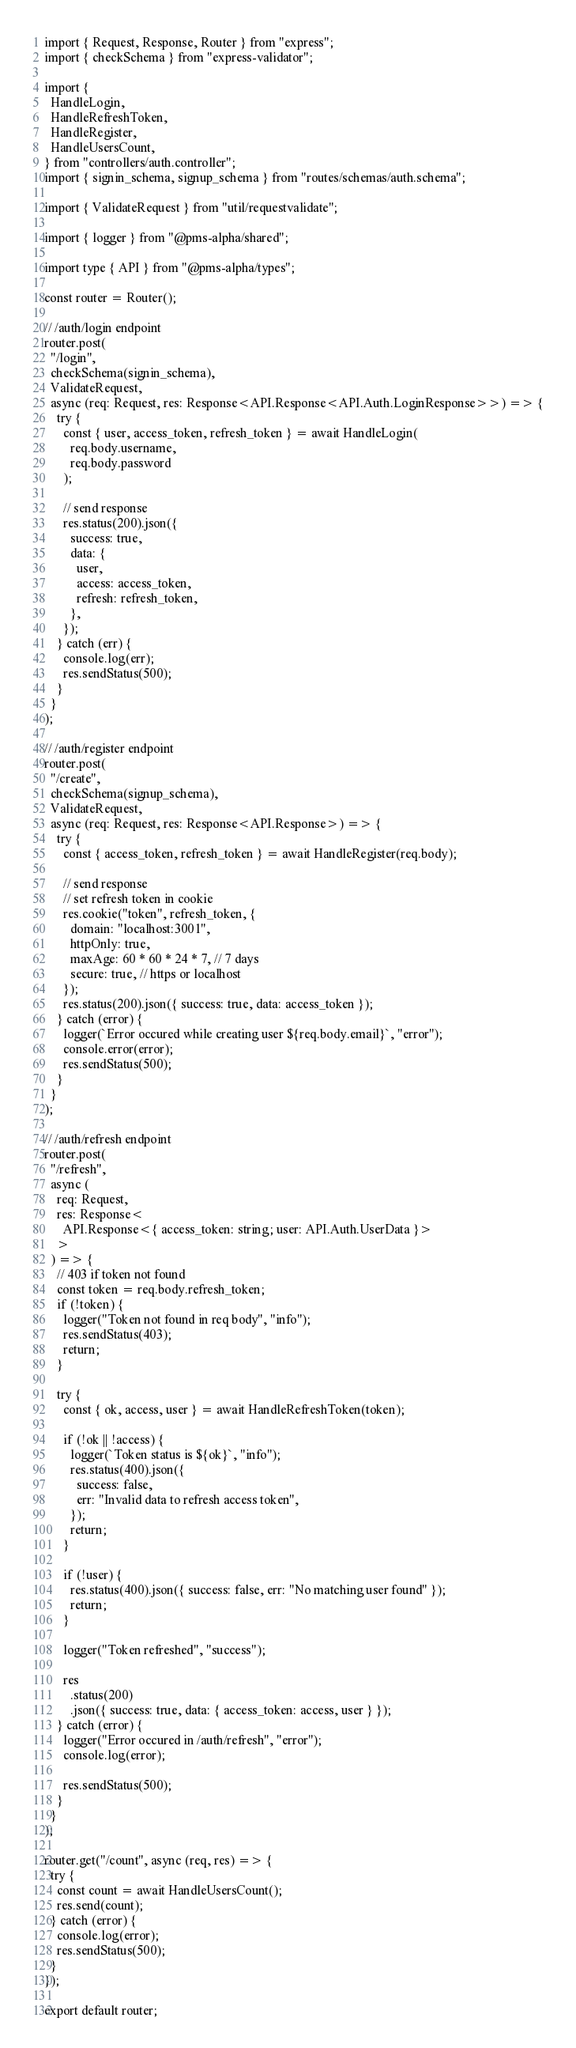<code> <loc_0><loc_0><loc_500><loc_500><_TypeScript_>import { Request, Response, Router } from "express";
import { checkSchema } from "express-validator";

import {
  HandleLogin,
  HandleRefreshToken,
  HandleRegister,
  HandleUsersCount,
} from "controllers/auth.controller";
import { signin_schema, signup_schema } from "routes/schemas/auth.schema";

import { ValidateRequest } from "util/requestvalidate";

import { logger } from "@pms-alpha/shared";

import type { API } from "@pms-alpha/types";

const router = Router();

// /auth/login endpoint
router.post(
  "/login",
  checkSchema(signin_schema),
  ValidateRequest,
  async (req: Request, res: Response<API.Response<API.Auth.LoginResponse>>) => {
    try {
      const { user, access_token, refresh_token } = await HandleLogin(
        req.body.username,
        req.body.password
      );

      // send response
      res.status(200).json({
        success: true,
        data: {
          user,
          access: access_token,
          refresh: refresh_token,
        },
      });
    } catch (err) {
      console.log(err);
      res.sendStatus(500);
    }
  }
);

// /auth/register endpoint
router.post(
  "/create",
  checkSchema(signup_schema),
  ValidateRequest,
  async (req: Request, res: Response<API.Response>) => {
    try {
      const { access_token, refresh_token } = await HandleRegister(req.body);

      // send response
      // set refresh token in cookie
      res.cookie("token", refresh_token, {
        domain: "localhost:3001",
        httpOnly: true,
        maxAge: 60 * 60 * 24 * 7, // 7 days
        secure: true, // https or localhost
      });
      res.status(200).json({ success: true, data: access_token });
    } catch (error) {
      logger(`Error occured while creating user ${req.body.email}`, "error");
      console.error(error);
      res.sendStatus(500);
    }
  }
);

// /auth/refresh endpoint
router.post(
  "/refresh",
  async (
    req: Request,
    res: Response<
      API.Response<{ access_token: string; user: API.Auth.UserData }>
    >
  ) => {
    // 403 if token not found
    const token = req.body.refresh_token;
    if (!token) {
      logger("Token not found in req body", "info");
      res.sendStatus(403);
      return;
    }

    try {
      const { ok, access, user } = await HandleRefreshToken(token);

      if (!ok || !access) {
        logger(`Token status is ${ok}`, "info");
        res.status(400).json({
          success: false,
          err: "Invalid data to refresh access token",
        });
        return;
      }

      if (!user) {
        res.status(400).json({ success: false, err: "No matching user found" });
        return;
      }

      logger("Token refreshed", "success");

      res
        .status(200)
        .json({ success: true, data: { access_token: access, user } });
    } catch (error) {
      logger("Error occured in /auth/refresh", "error");
      console.log(error);

      res.sendStatus(500);
    }
  }
);

router.get("/count", async (req, res) => {
  try {
    const count = await HandleUsersCount();
    res.send(count);
  } catch (error) {
    console.log(error);
    res.sendStatus(500);
  }
});

export default router;
</code> 